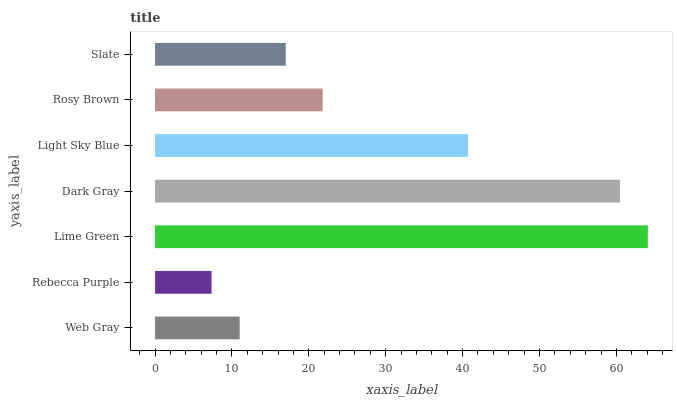Is Rebecca Purple the minimum?
Answer yes or no. Yes. Is Lime Green the maximum?
Answer yes or no. Yes. Is Lime Green the minimum?
Answer yes or no. No. Is Rebecca Purple the maximum?
Answer yes or no. No. Is Lime Green greater than Rebecca Purple?
Answer yes or no. Yes. Is Rebecca Purple less than Lime Green?
Answer yes or no. Yes. Is Rebecca Purple greater than Lime Green?
Answer yes or no. No. Is Lime Green less than Rebecca Purple?
Answer yes or no. No. Is Rosy Brown the high median?
Answer yes or no. Yes. Is Rosy Brown the low median?
Answer yes or no. Yes. Is Dark Gray the high median?
Answer yes or no. No. Is Web Gray the low median?
Answer yes or no. No. 